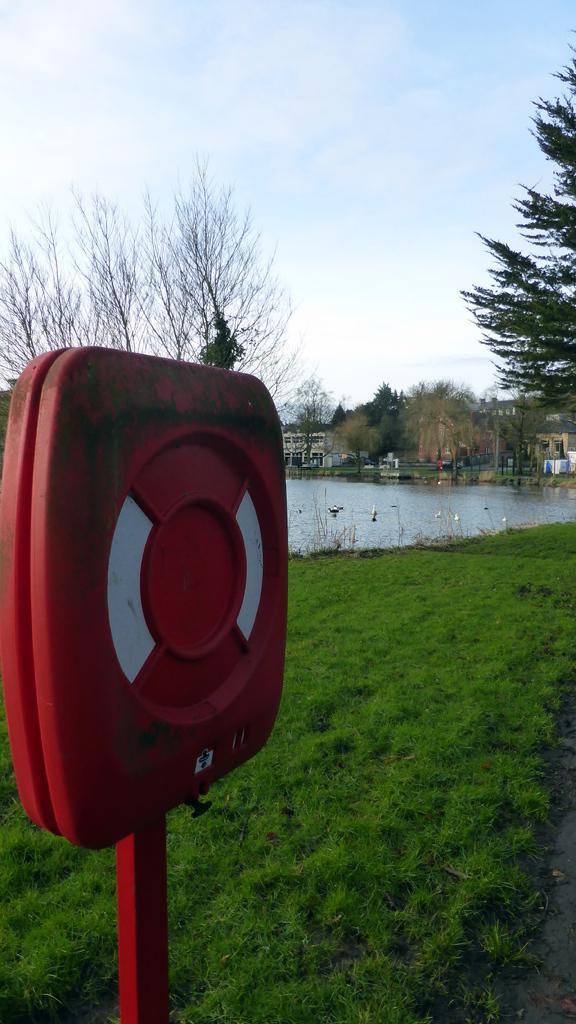Describe this image in one or two sentences. In this image in the foreground there is one board at the bottom there is a grass and in the center there is one river, and in the background there are some houses trees. On the top of the image there is sky. 